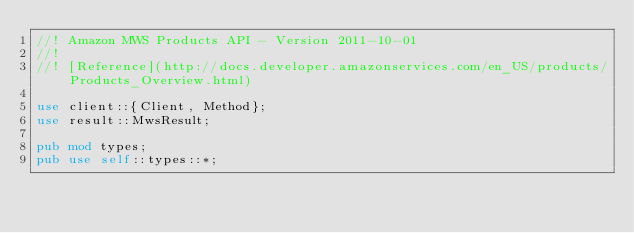Convert code to text. <code><loc_0><loc_0><loc_500><loc_500><_Rust_>//! Amazon MWS Products API - Version 2011-10-01
//!
//! [Reference](http://docs.developer.amazonservices.com/en_US/products/Products_Overview.html)

use client::{Client, Method};
use result::MwsResult;

pub mod types;
pub use self::types::*;
</code> 